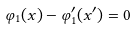<formula> <loc_0><loc_0><loc_500><loc_500>\varphi _ { 1 } ( x ) - \varphi ^ { \prime } _ { 1 } ( x ^ { \prime } ) = 0</formula> 